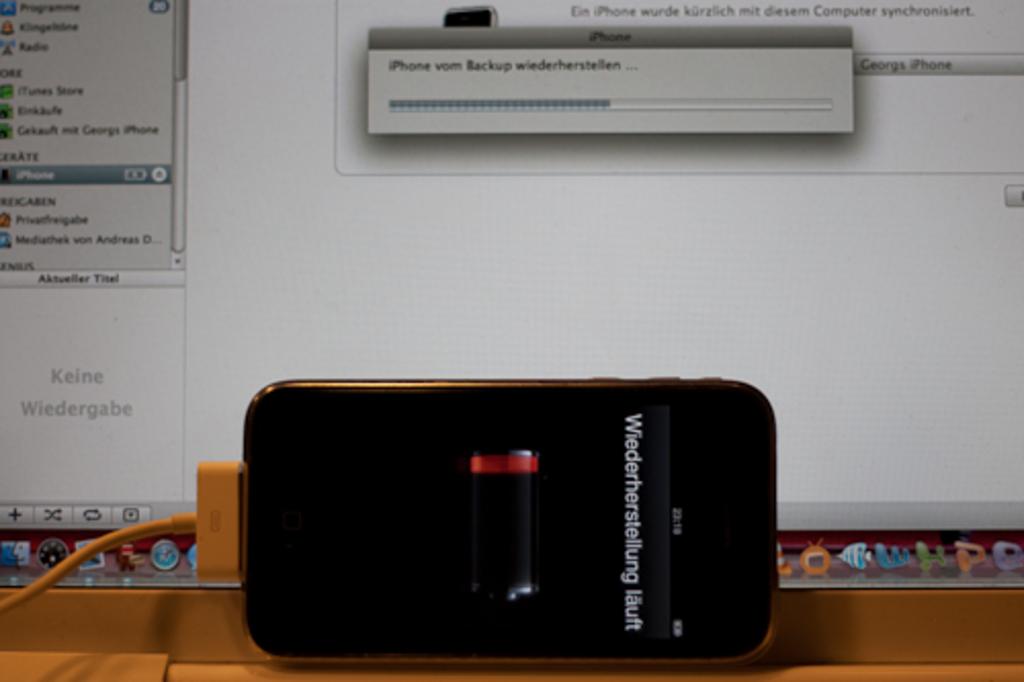What language is spoken or shown on the phone?
Your answer should be compact. Unanswerable. What does the phone say?
Your response must be concise. Wiederherstellung lauft. 